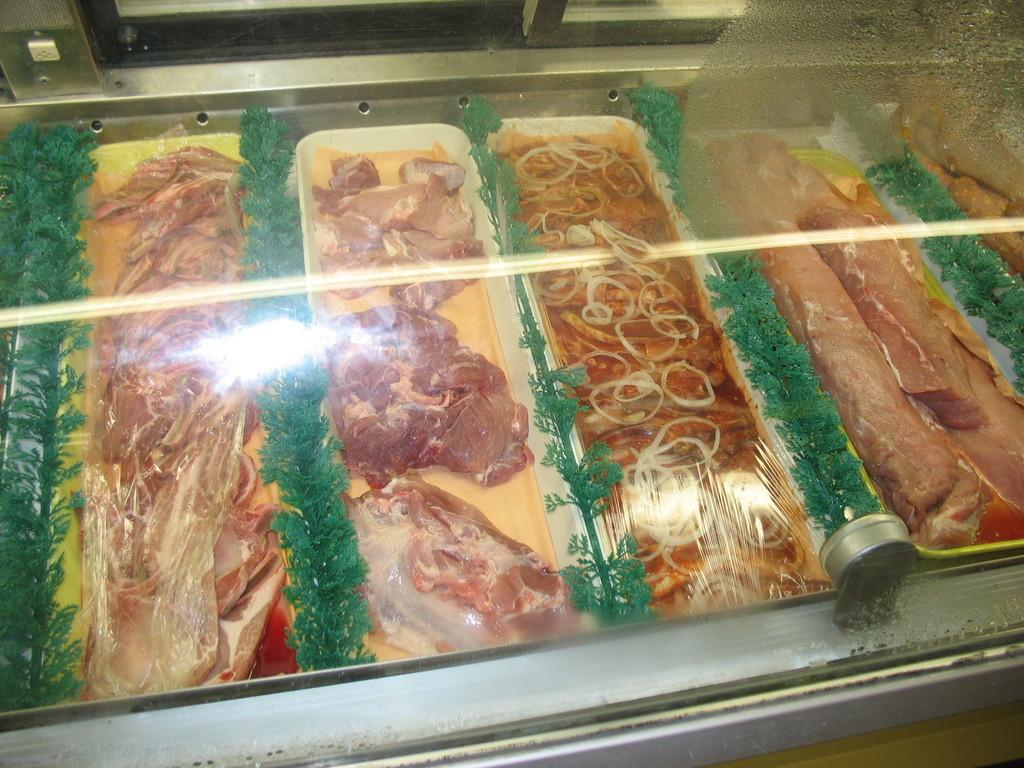What type of food can be seen in the image? There are trays of meat in the image. What is used as decoration between the trays of meat? Plants are used as garnish between the trays of meat. How are the trays of meat and garnish displayed in the image? The trays of meat and garnish are placed under a glass. What is the level of anger displayed by the legs in the image? There are no legs present in the image, and therefore no level of anger can be determined. 